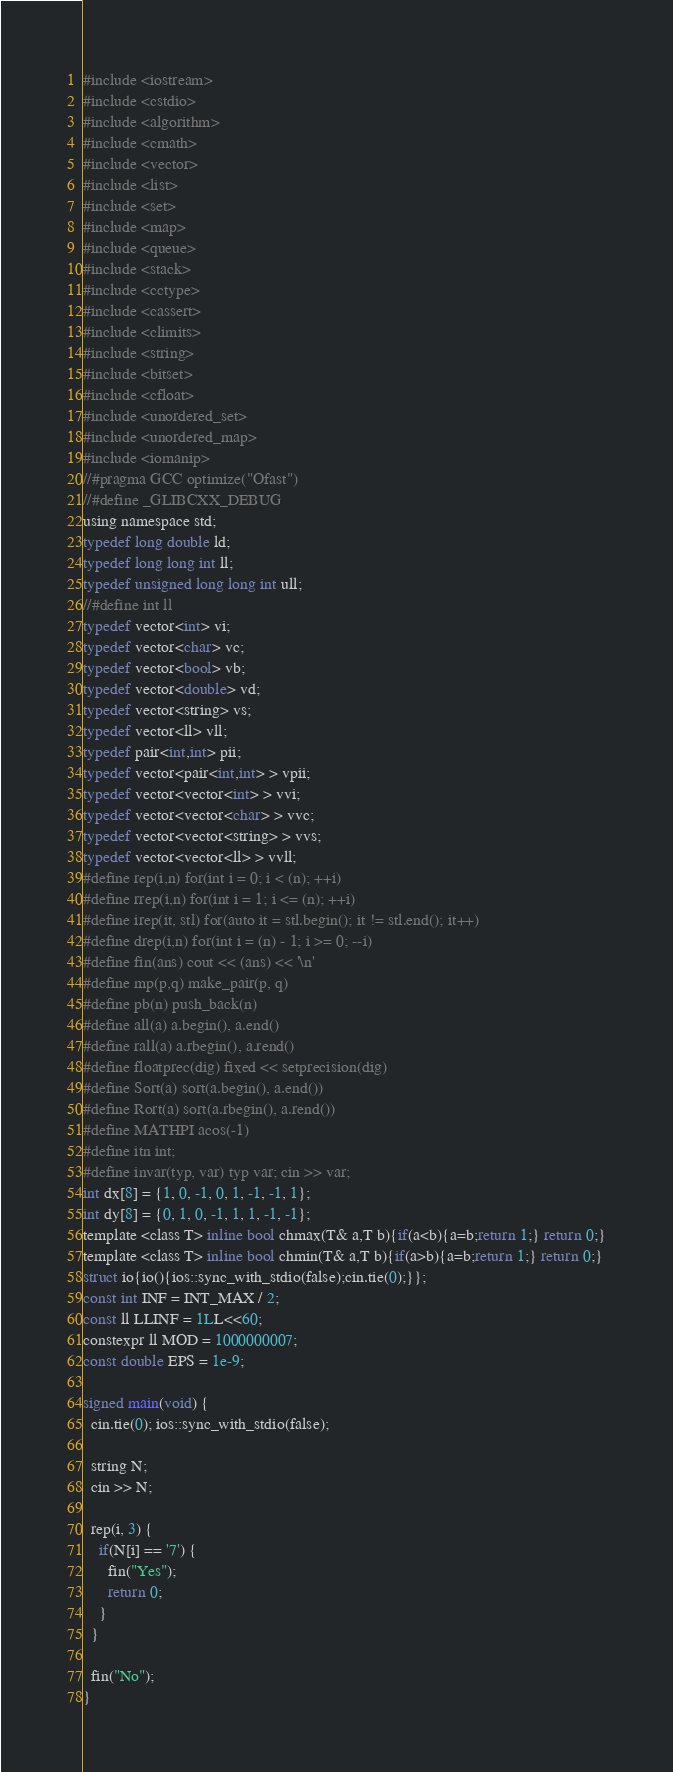Convert code to text. <code><loc_0><loc_0><loc_500><loc_500><_C_>#include <iostream>
#include <cstdio>
#include <algorithm>
#include <cmath>
#include <vector>
#include <list>
#include <set>
#include <map>
#include <queue>
#include <stack>
#include <cctype>
#include <cassert>
#include <climits>
#include <string>
#include <bitset>
#include <cfloat>
#include <unordered_set>
#include <unordered_map>
#include <iomanip>
//#pragma GCC optimize("Ofast")
//#define _GLIBCXX_DEBUG
using namespace std;
typedef long double ld;
typedef long long int ll;
typedef unsigned long long int ull;
//#define int ll
typedef vector<int> vi;
typedef vector<char> vc;
typedef vector<bool> vb;
typedef vector<double> vd;
typedef vector<string> vs;
typedef vector<ll> vll;
typedef pair<int,int> pii;
typedef vector<pair<int,int> > vpii;
typedef vector<vector<int> > vvi;
typedef vector<vector<char> > vvc;
typedef vector<vector<string> > vvs;
typedef vector<vector<ll> > vvll;
#define rep(i,n) for(int i = 0; i < (n); ++i)
#define rrep(i,n) for(int i = 1; i <= (n); ++i)
#define irep(it, stl) for(auto it = stl.begin(); it != stl.end(); it++)
#define drep(i,n) for(int i = (n) - 1; i >= 0; --i)
#define fin(ans) cout << (ans) << '\n'
#define mp(p,q) make_pair(p, q)
#define pb(n) push_back(n)
#define all(a) a.begin(), a.end()
#define rall(a) a.rbegin(), a.rend()
#define floatprec(dig) fixed << setprecision(dig)
#define Sort(a) sort(a.begin(), a.end())
#define Rort(a) sort(a.rbegin(), a.rend())
#define MATHPI acos(-1)
#define itn int;
#define invar(typ, var) typ var; cin >> var;
int dx[8] = {1, 0, -1, 0, 1, -1, -1, 1};
int dy[8] = {0, 1, 0, -1, 1, 1, -1, -1};
template <class T> inline bool chmax(T& a,T b){if(a<b){a=b;return 1;} return 0;}
template <class T> inline bool chmin(T& a,T b){if(a>b){a=b;return 1;} return 0;}
struct io{io(){ios::sync_with_stdio(false);cin.tie(0);}};
const int INF = INT_MAX / 2;
const ll LLINF = 1LL<<60;
constexpr ll MOD = 1000000007;
const double EPS = 1e-9;

signed main(void) {
  cin.tie(0); ios::sync_with_stdio(false);
  
  string N;
  cin >> N;
  
  rep(i, 3) {
    if(N[i] == '7') {
      fin("Yes");
      return 0;
    }
  }
  
  fin("No");
}</code> 